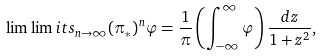Convert formula to latex. <formula><loc_0><loc_0><loc_500><loc_500>\lim \lim i t s _ { n \to \infty } ( \pi _ { * } ) ^ { n } \varphi = \frac { 1 } { \pi } \left ( \int _ { - \infty } ^ { \infty } \varphi \right ) \frac { d z } { 1 + z ^ { 2 } } ,</formula> 